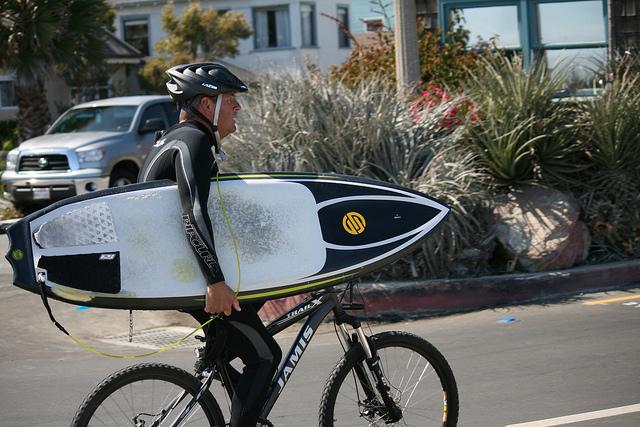What is the big object?
Be succinct. Surfboard. Are the bikes new?
Write a very short answer. Yes. Who is carrying  a surfboard??
Short answer required. Man. How long is the surfboard?
Short answer required. 5 ft. What color is the bike?
Concise answer only. Black. What color is the surfboard?
Write a very short answer. White and black. 